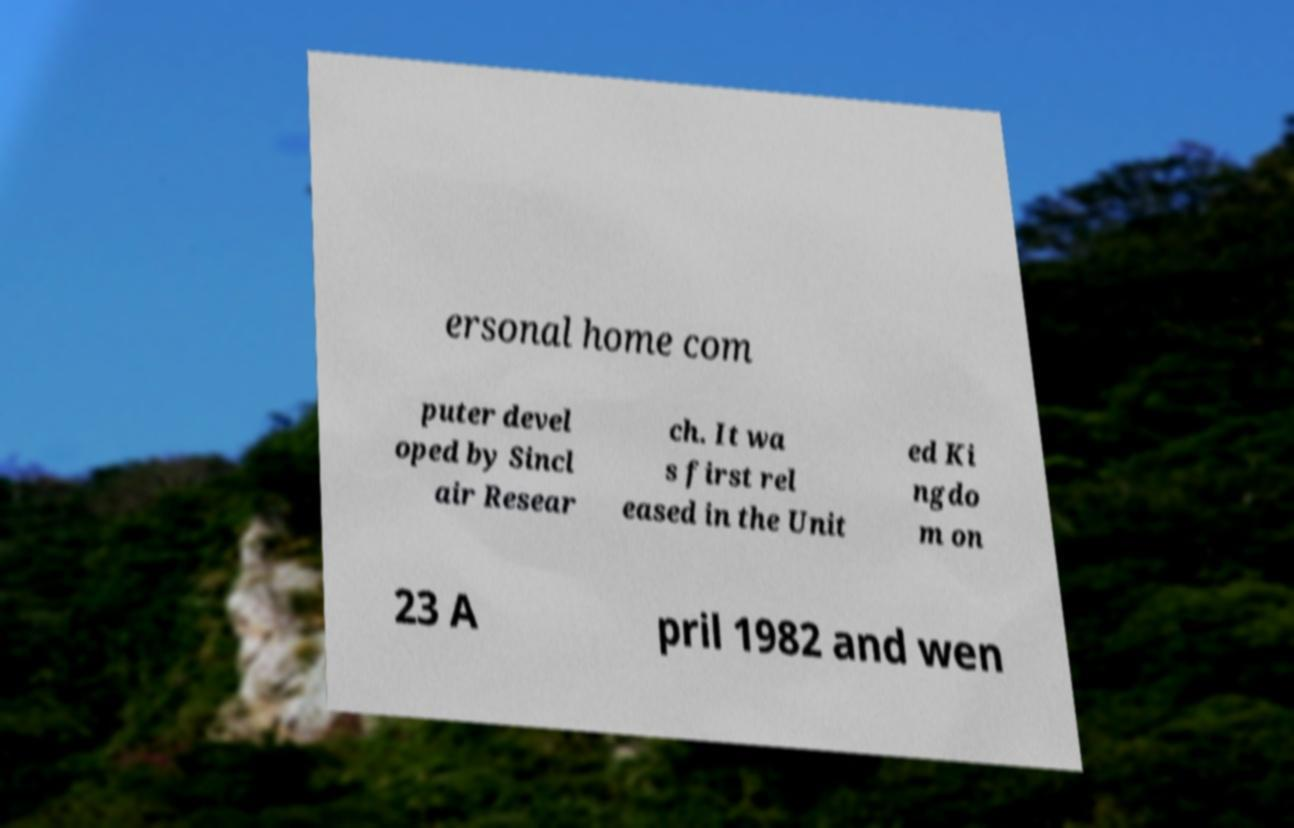Could you assist in decoding the text presented in this image and type it out clearly? ersonal home com puter devel oped by Sincl air Resear ch. It wa s first rel eased in the Unit ed Ki ngdo m on 23 A pril 1982 and wen 